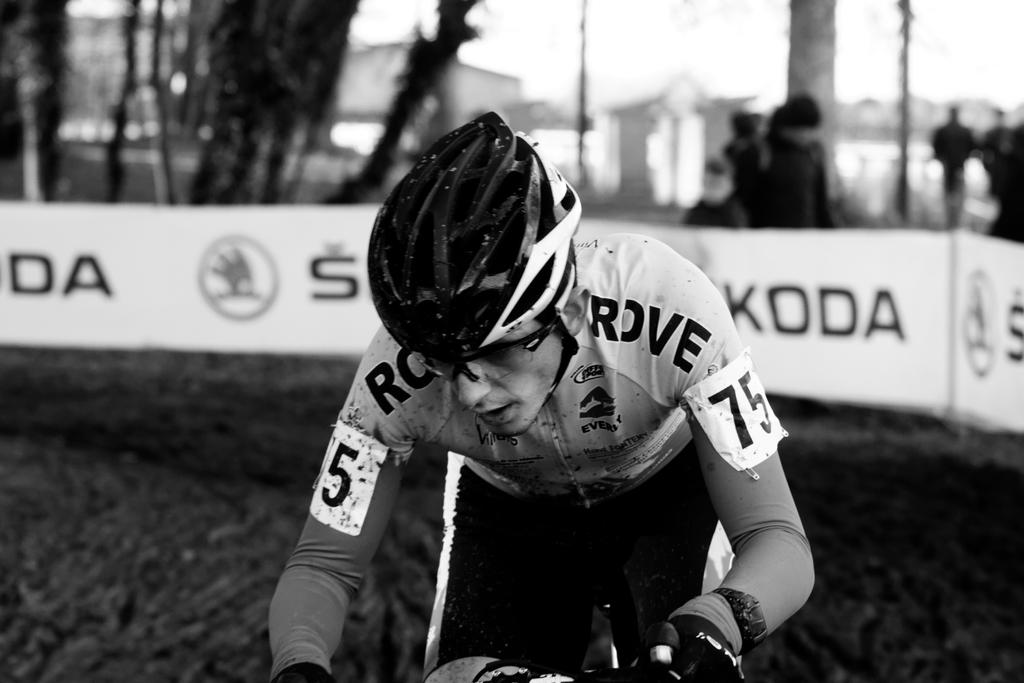What is the person in the image doing? The person is cycling on a path. What is the person wearing while cycling? The person is wearing a helmet. What can be seen in the background of the image? There are banners, trees, and buildings in the background of the image. How is the background of the image depicted? The background is blurred. What type of egg is being used to make juice in the image? There is no egg or juice present in the image. 